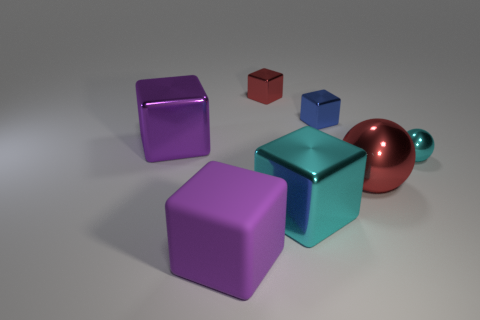What time of day does the lighting in the image suggest? The lighting in the image appears to be soft and diffused, with no harsh shadows or bright highlights, which could indicate an overcast day or an interior setting with ambient lighting rather than a specific time of day. 